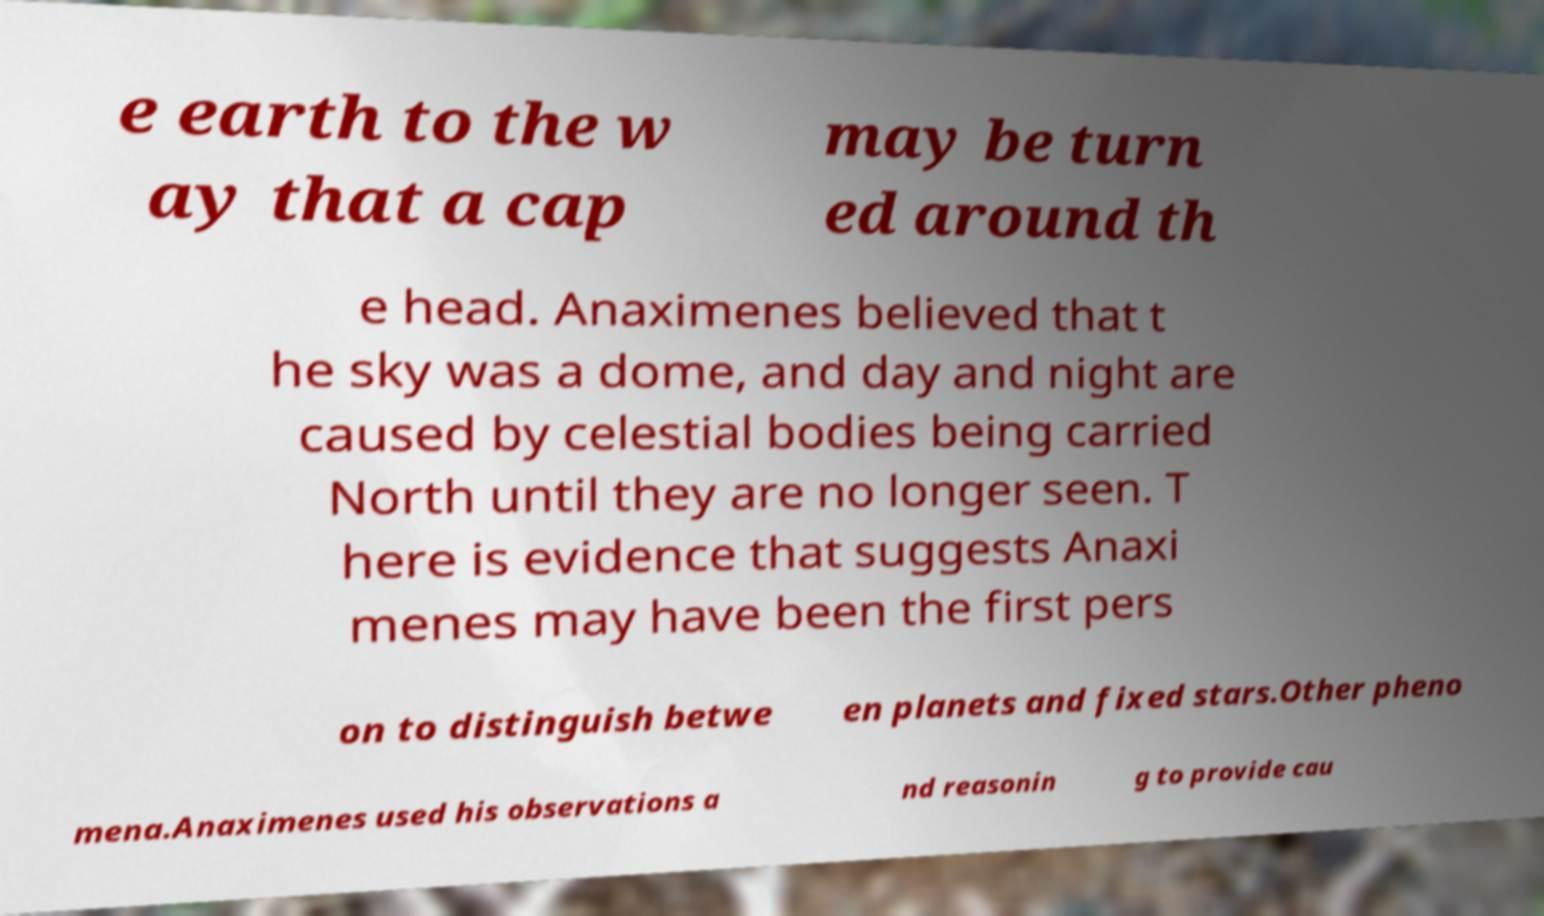Could you extract and type out the text from this image? e earth to the w ay that a cap may be turn ed around th e head. Anaximenes believed that t he sky was a dome, and day and night are caused by celestial bodies being carried North until they are no longer seen. T here is evidence that suggests Anaxi menes may have been the first pers on to distinguish betwe en planets and fixed stars.Other pheno mena.Anaximenes used his observations a nd reasonin g to provide cau 